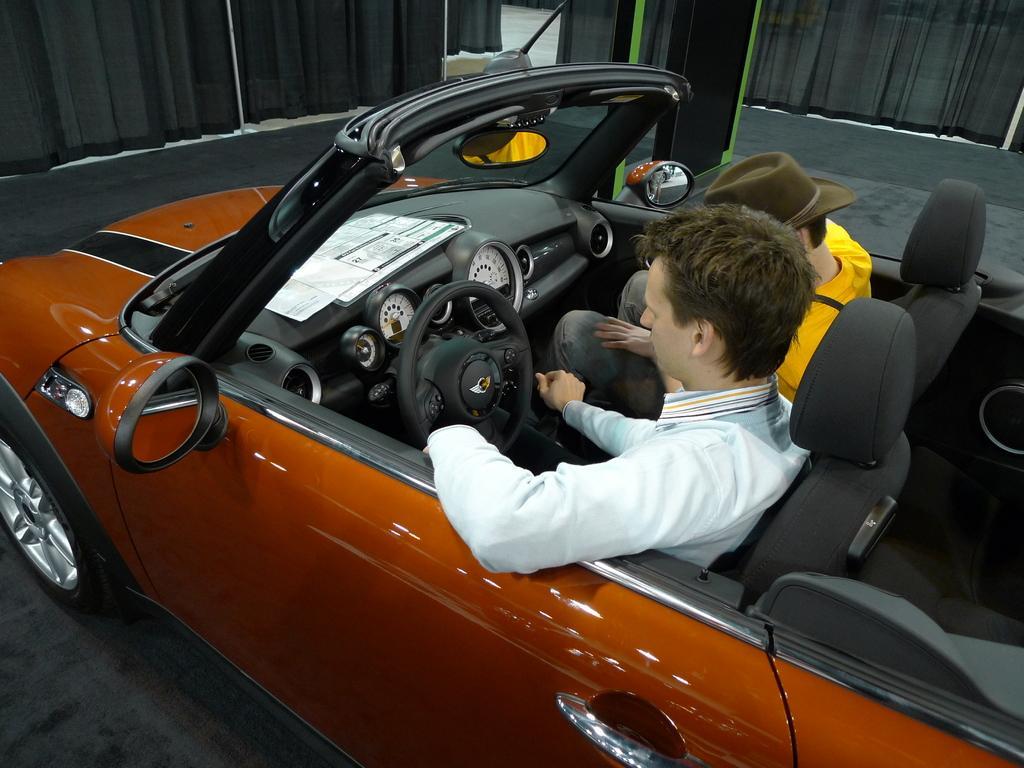Can you describe this image briefly? In this image we can see two persons are sitting in a car on the floor. In the background we can see curtains and objects. 